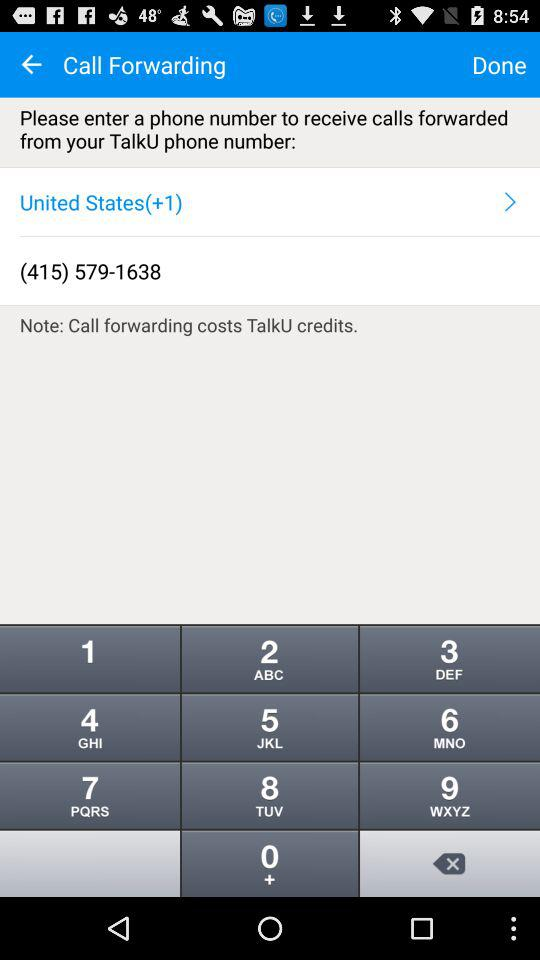What is the selected country? The selected country is the "United States". 